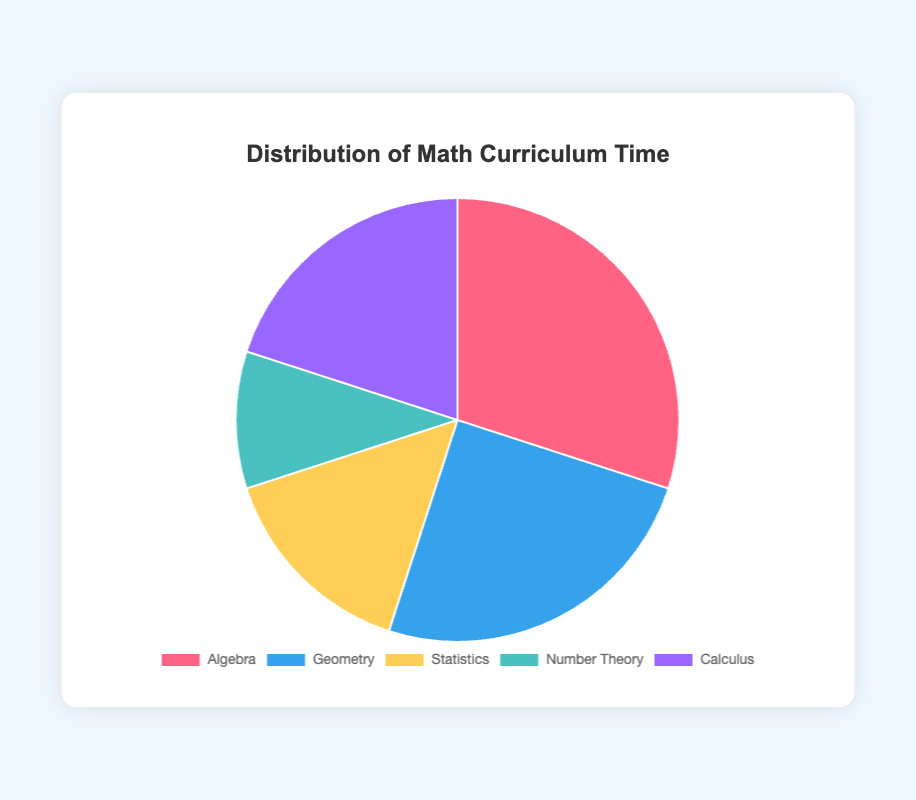Which subject occupies the highest percentage of the curriculum time? By observing the pie chart, we see that Algebra has the largest slice. Hence, Algebra occupies the highest percentage of the curriculum time.
Answer: Algebra Which two subjects combined take up the least curriculum time? The subjects with the smallest slices are Statistics (15%) and Number Theory (10%). Adding them together gives 15% + 10% = 25%, which is less than any other pair's total.
Answer: Statistics and Number Theory How much more curriculum time is allocated to Algebra compared to Calculus? The pie chart shows Algebra (30%) and Calculus (20%). The difference in time is 30% - 20% = 10%.
Answer: 10% Which subject is allocated the same time as the sum of Statistics and Number Theory? Statistics is 15% and Number Theory is 10%. Their sum is 15% + 10% = 25%. The subject with 25% is Geometry.
Answer: Geometry If the total curriculum time is 40 hours a week, how many hours are spent on Geometry weekly? Geometry takes up 25% of the time. 25% of 40 hours is (0.25 * 40) = 10 hours.
Answer: 10 hours Is the curriculum time for Geometry greater than the sum of Number Theory and Statistics? Geometry has 25%, and the sum of Number Theory (10%) and Statistics (15%) is 10% + 15% = 25%. This means Geometry (25%) is equal to the sum.
Answer: No, they are equal Which subject gets double the curriculum time of Number Theory? Number Theory has 10%, and double of this is 20%. The subject with 20% is Calculus.
Answer: Calculus Which slice representing a subject is colored yellow and what percentage of the curriculum does it represent? By noting the chart’s color coding, the yellow slice corresponds to Statistics, which represents 15% of the curriculum.
Answer: Statistics, 15% If Algebra's curriculum time is increased by 5%, what would its new percentage be? Currently, Algebra is 30%. Adding 5% makes it 30% + 5% = 35%.
Answer: 35% Which subject's slice is blue in the pie chart, and how does its time percentage compare to Calculus? The blue slice represents Geometry at 25%. Calculus is 20%, so Geometry's time (25%) is greater than Calculus by 5%.
Answer: Geometry, greater by 5% 